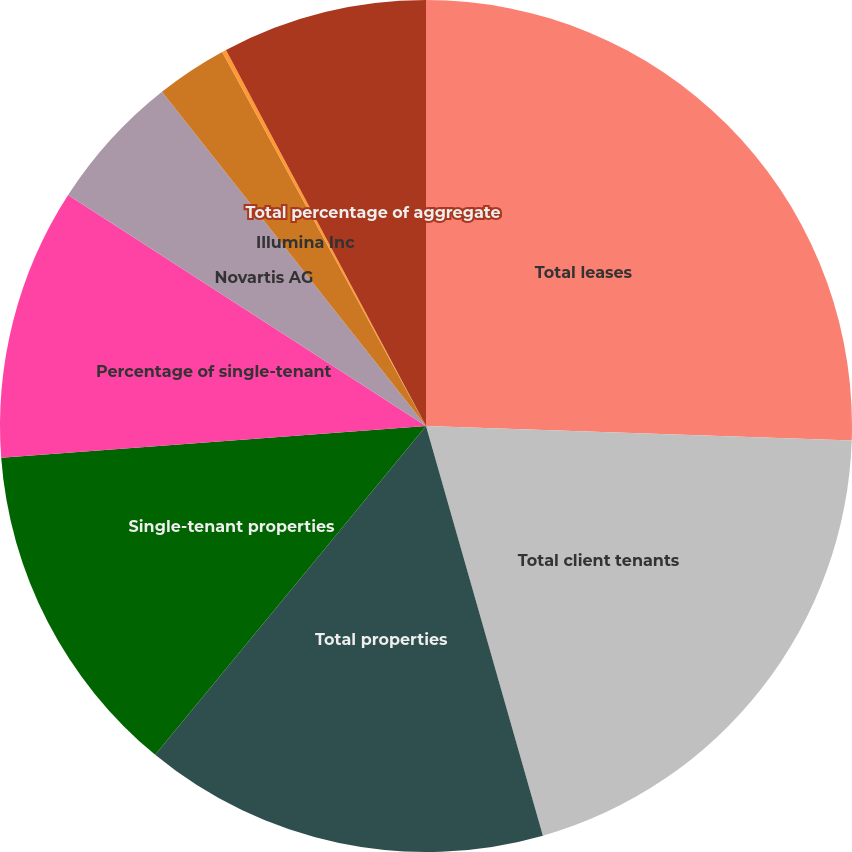Convert chart to OTSL. <chart><loc_0><loc_0><loc_500><loc_500><pie_chart><fcel>Total leases<fcel>Total client tenants<fcel>Total properties<fcel>Single-tenant properties<fcel>Percentage of single-tenant<fcel>Novartis AG<fcel>Illumina Inc<fcel>New York University<fcel>Total percentage of aggregate<nl><fcel>25.54%<fcel>20.04%<fcel>15.39%<fcel>12.85%<fcel>10.31%<fcel>5.24%<fcel>2.7%<fcel>0.16%<fcel>7.78%<nl></chart> 